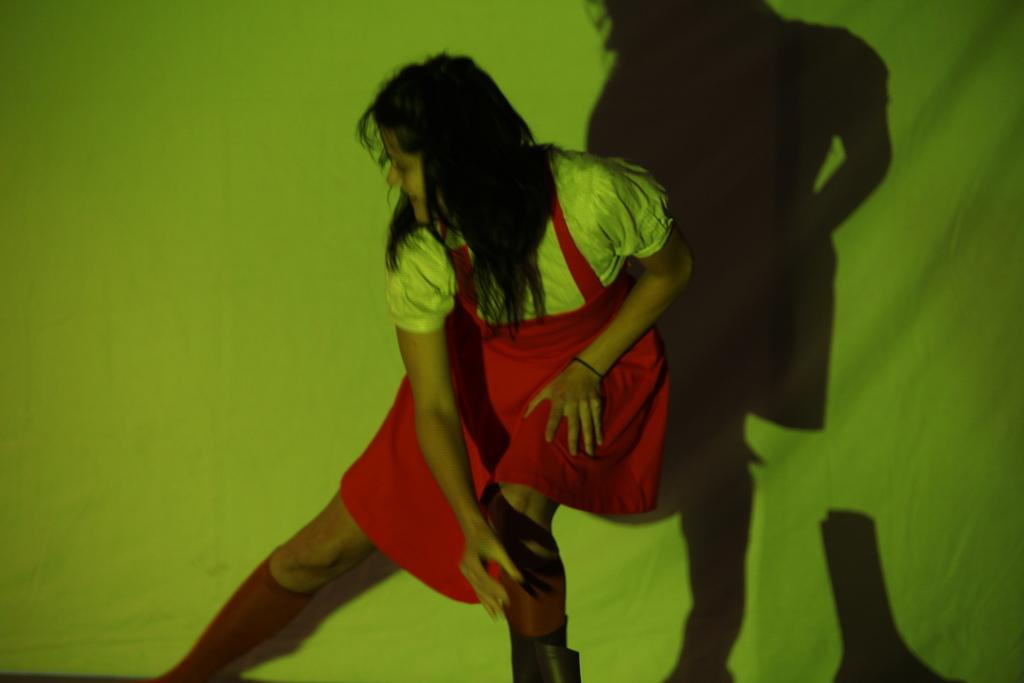Who is the main subject in the image? There is a girl in the image. What is the girl wearing? The girl is wearing a dress. What is the girl doing in the image? The girl is dancing. What color is the background of the image? The background of the image is green in color. What type of juice is the girl holding in the image? There is no juice present in the image; the girl is dancing and wearing a dress. Can you see any popcorn in the image? There is no popcorn present in the image; the main subject is a girl dancing in a green background. 